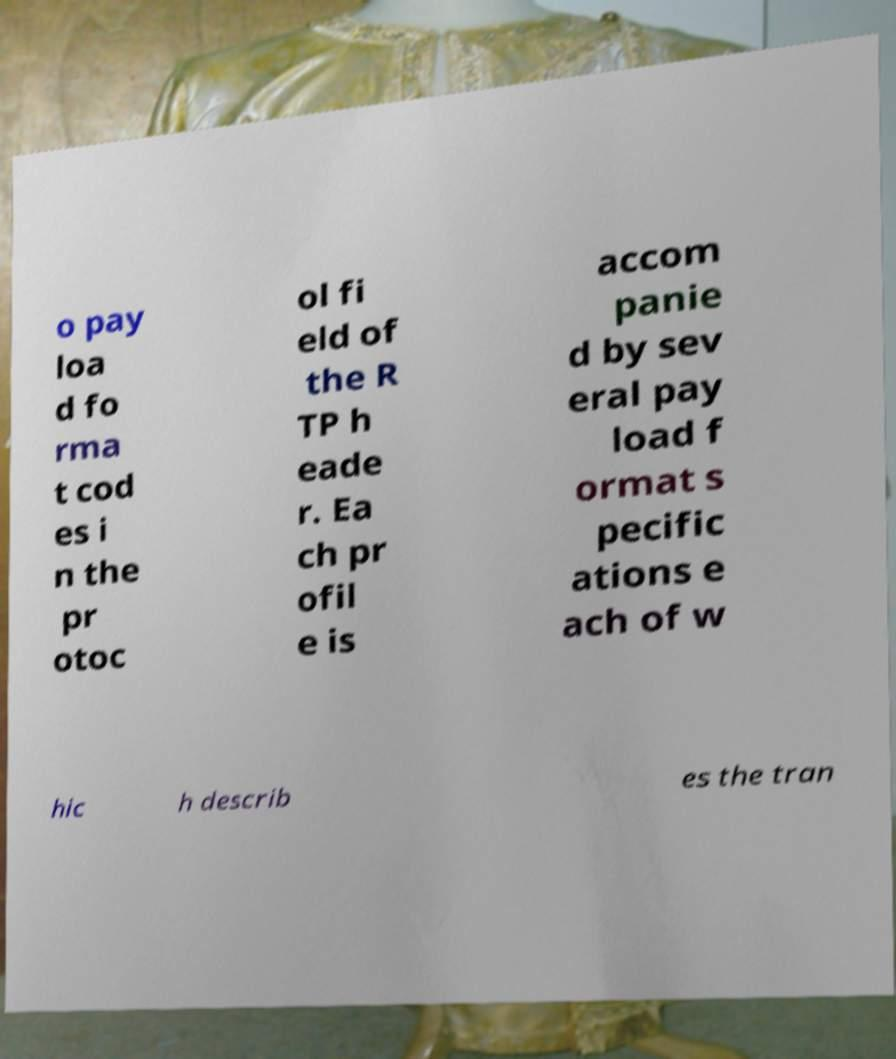Please read and relay the text visible in this image. What does it say? o pay loa d fo rma t cod es i n the pr otoc ol fi eld of the R TP h eade r. Ea ch pr ofil e is accom panie d by sev eral pay load f ormat s pecific ations e ach of w hic h describ es the tran 